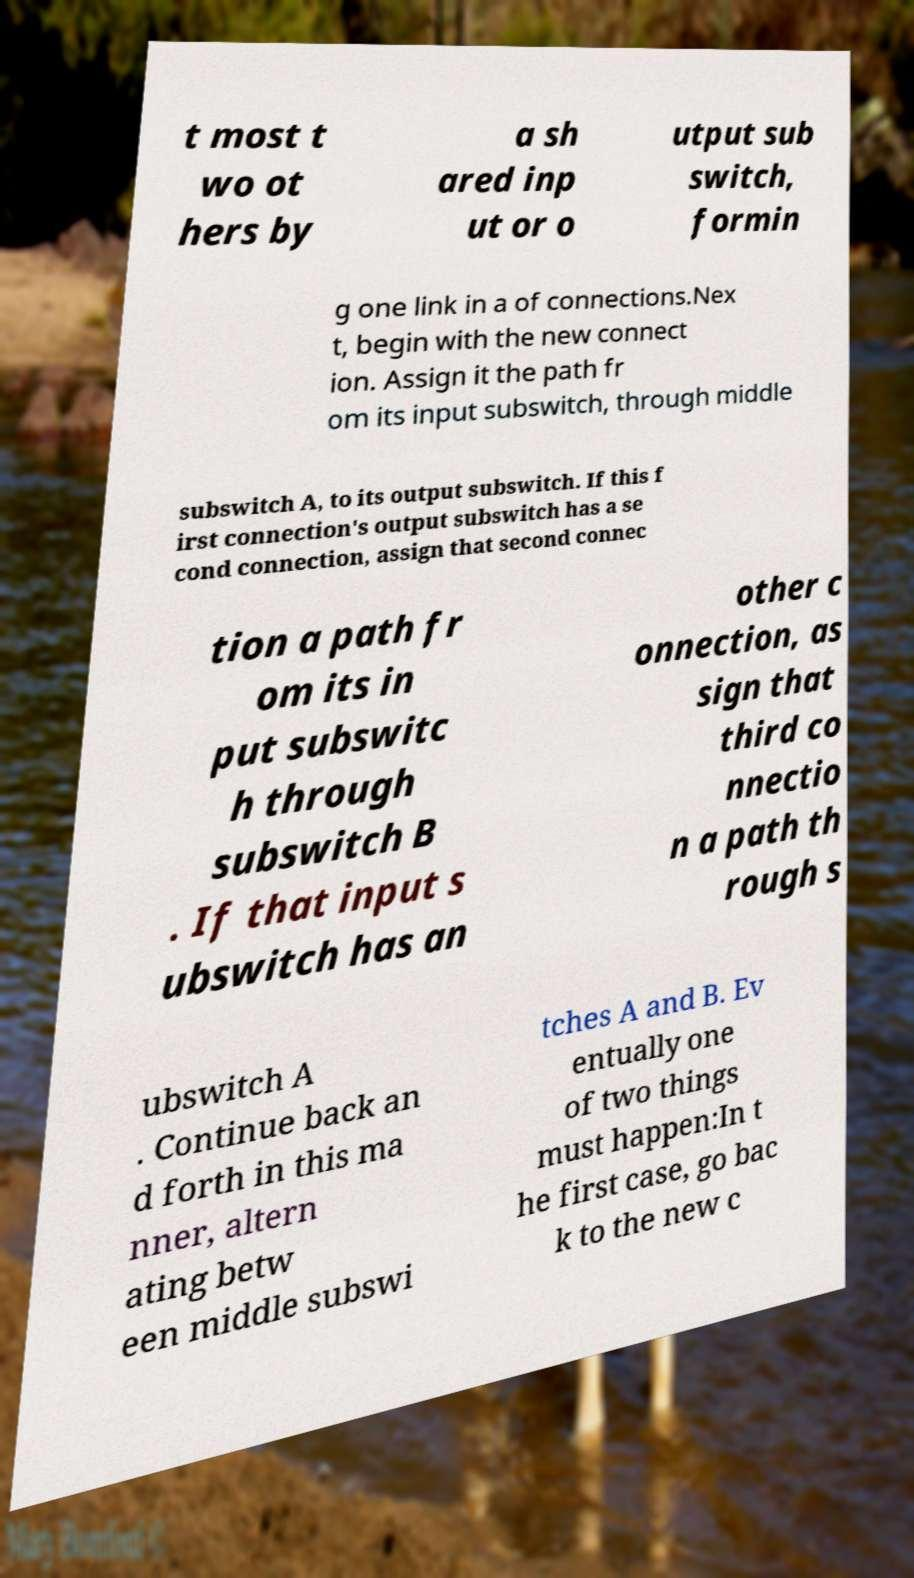I need the written content from this picture converted into text. Can you do that? t most t wo ot hers by a sh ared inp ut or o utput sub switch, formin g one link in a of connections.Nex t, begin with the new connect ion. Assign it the path fr om its input subswitch, through middle subswitch A, to its output subswitch. If this f irst connection's output subswitch has a se cond connection, assign that second connec tion a path fr om its in put subswitc h through subswitch B . If that input s ubswitch has an other c onnection, as sign that third co nnectio n a path th rough s ubswitch A . Continue back an d forth in this ma nner, altern ating betw een middle subswi tches A and B. Ev entually one of two things must happen:In t he first case, go bac k to the new c 